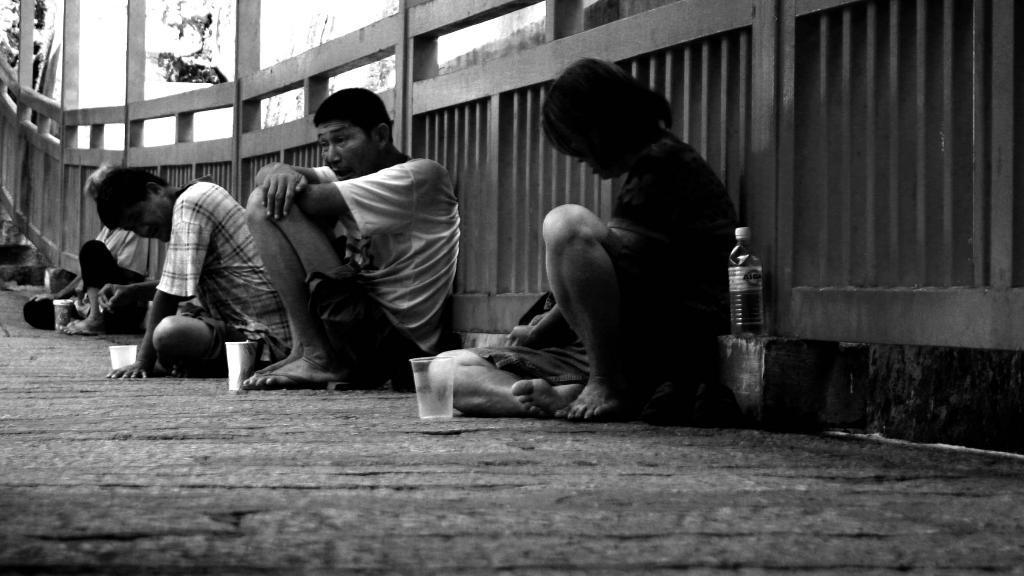Could you give a brief overview of what you see in this image? In this image there are four people sat on the surface, leaning into a wooden fence, there are four glasses placed each one in front of them. 